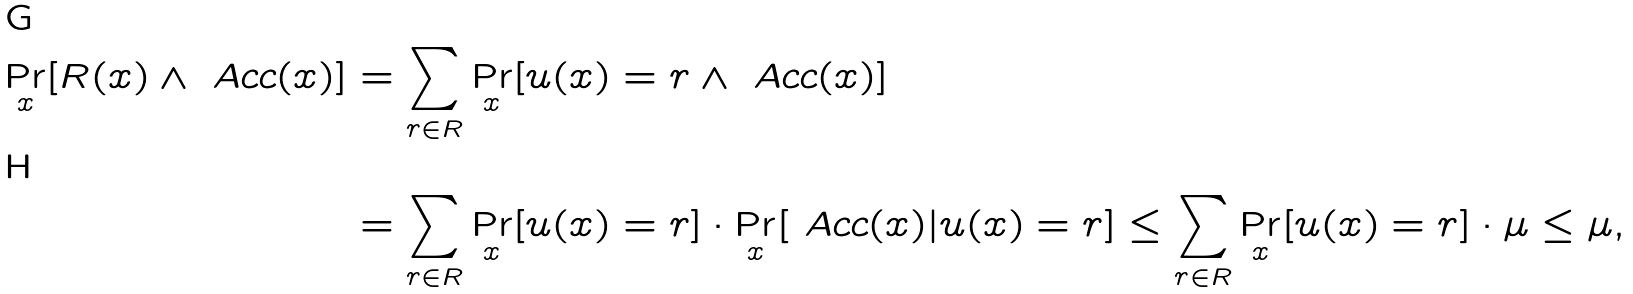Convert formula to latex. <formula><loc_0><loc_0><loc_500><loc_500>\Pr _ { x } [ R ( x ) \wedge \ A c c ( x ) ] & = \sum _ { r \in R } \Pr _ { x } [ u ( x ) = r \wedge \ A c c ( x ) ] \\ & = \sum _ { r \in R } \Pr _ { x } [ u ( x ) = r ] \cdot \Pr _ { x } [ \ A c c ( x ) | u ( x ) = r ] \leq \sum _ { r \in R } \Pr _ { x } [ u ( x ) = r ] \cdot \mu \leq \mu ,</formula> 